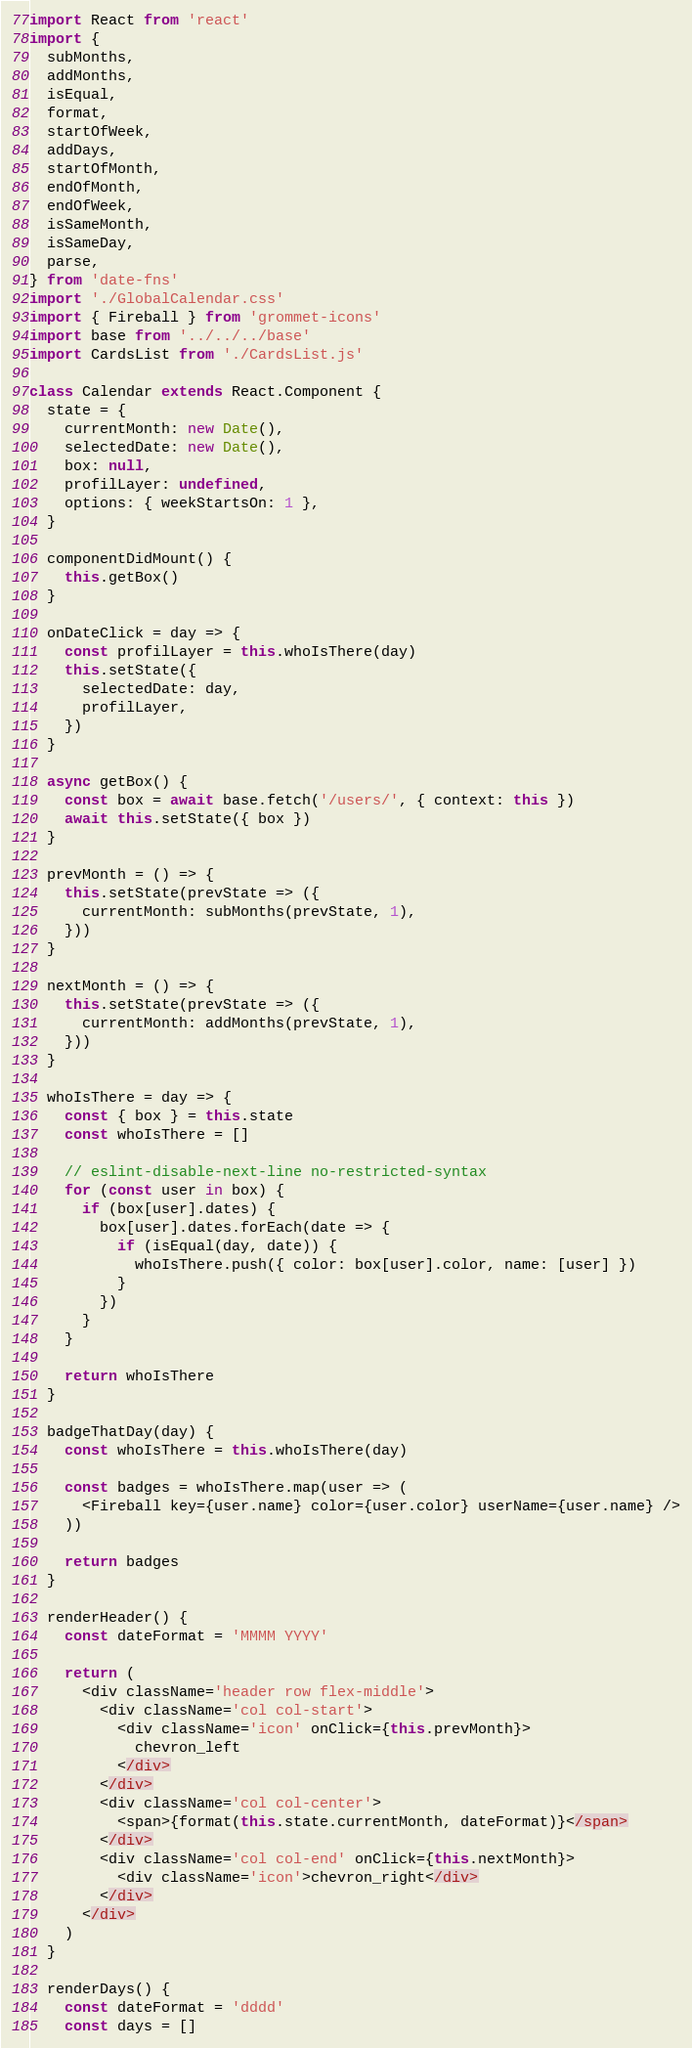Convert code to text. <code><loc_0><loc_0><loc_500><loc_500><_JavaScript_>import React from 'react'
import {
  subMonths,
  addMonths,
  isEqual,
  format,
  startOfWeek,
  addDays,
  startOfMonth,
  endOfMonth,
  endOfWeek,
  isSameMonth,
  isSameDay,
  parse,
} from 'date-fns'
import './GlobalCalendar.css'
import { Fireball } from 'grommet-icons'
import base from '../../../base'
import CardsList from './CardsList.js'

class Calendar extends React.Component {
  state = {
    currentMonth: new Date(),
    selectedDate: new Date(),
    box: null,
    profilLayer: undefined,
    options: { weekStartsOn: 1 },
  }

  componentDidMount() {
    this.getBox()
  }

  onDateClick = day => {
    const profilLayer = this.whoIsThere(day)
    this.setState({
      selectedDate: day,
      profilLayer,
    })
  }

  async getBox() {
    const box = await base.fetch('/users/', { context: this })
    await this.setState({ box })
  }

  prevMonth = () => {
    this.setState(prevState => ({
      currentMonth: subMonths(prevState, 1),
    }))
  }

  nextMonth = () => {
    this.setState(prevState => ({
      currentMonth: addMonths(prevState, 1),
    }))
  }

  whoIsThere = day => {
    const { box } = this.state
    const whoIsThere = []

    // eslint-disable-next-line no-restricted-syntax
    for (const user in box) {
      if (box[user].dates) {
        box[user].dates.forEach(date => {
          if (isEqual(day, date)) {
            whoIsThere.push({ color: box[user].color, name: [user] })
          }
        })
      }
    }

    return whoIsThere
  }

  badgeThatDay(day) {
    const whoIsThere = this.whoIsThere(day)

    const badges = whoIsThere.map(user => (
      <Fireball key={user.name} color={user.color} userName={user.name} />
    ))

    return badges
  }

  renderHeader() {
    const dateFormat = 'MMMM YYYY'

    return (
      <div className='header row flex-middle'>
        <div className='col col-start'>
          <div className='icon' onClick={this.prevMonth}>
            chevron_left
          </div>
        </div>
        <div className='col col-center'>
          <span>{format(this.state.currentMonth, dateFormat)}</span>
        </div>
        <div className='col col-end' onClick={this.nextMonth}>
          <div className='icon'>chevron_right</div>
        </div>
      </div>
    )
  }

  renderDays() {
    const dateFormat = 'dddd'
    const days = []</code> 